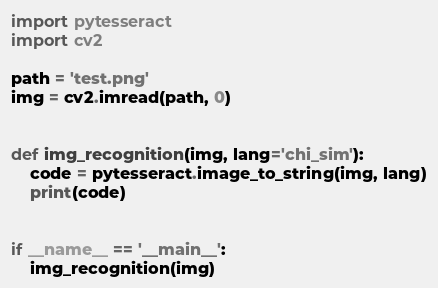Convert code to text. <code><loc_0><loc_0><loc_500><loc_500><_Python_>import pytesseract
import cv2

path = 'test.png'
img = cv2.imread(path, 0)


def img_recognition(img, lang='chi_sim'):
    code = pytesseract.image_to_string(img, lang)
    print(code)


if __name__ == '__main__':
    img_recognition(img)</code> 